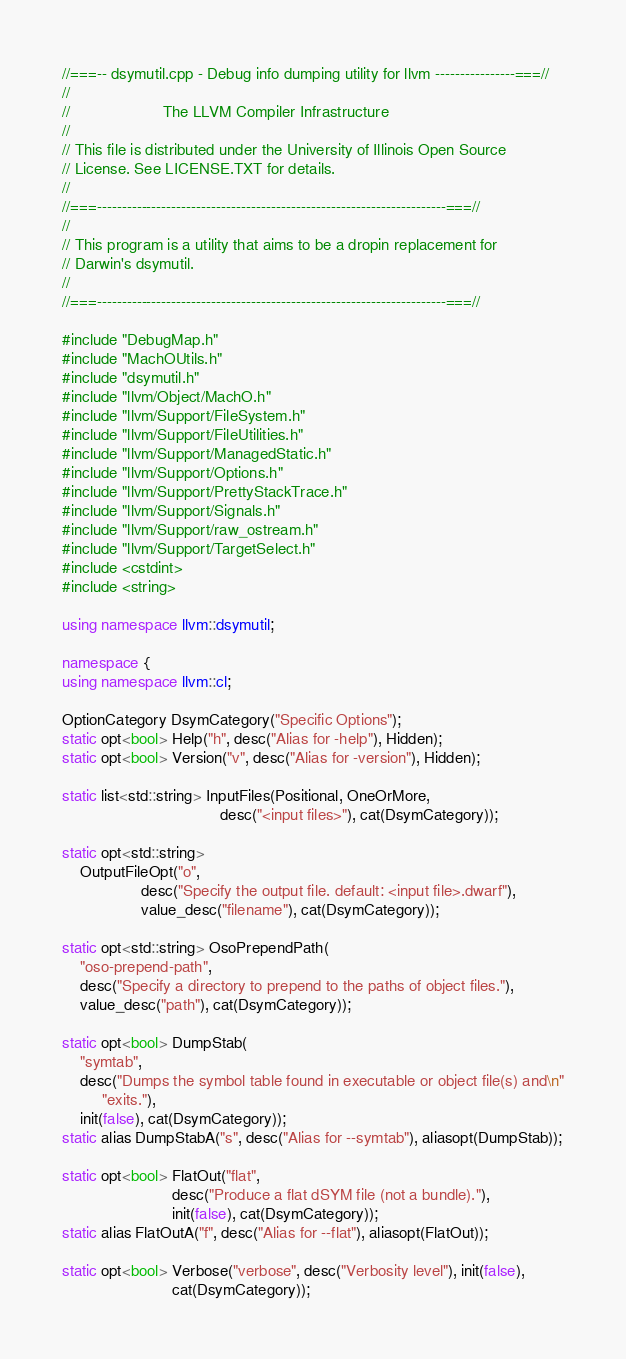<code> <loc_0><loc_0><loc_500><loc_500><_C++_>//===-- dsymutil.cpp - Debug info dumping utility for llvm ----------------===//
//
//                     The LLVM Compiler Infrastructure
//
// This file is distributed under the University of Illinois Open Source
// License. See LICENSE.TXT for details.
//
//===----------------------------------------------------------------------===//
//
// This program is a utility that aims to be a dropin replacement for
// Darwin's dsymutil.
//
//===----------------------------------------------------------------------===//

#include "DebugMap.h"
#include "MachOUtils.h"
#include "dsymutil.h"
#include "llvm/Object/MachO.h"
#include "llvm/Support/FileSystem.h"
#include "llvm/Support/FileUtilities.h"
#include "llvm/Support/ManagedStatic.h"
#include "llvm/Support/Options.h"
#include "llvm/Support/PrettyStackTrace.h"
#include "llvm/Support/Signals.h"
#include "llvm/Support/raw_ostream.h"
#include "llvm/Support/TargetSelect.h"
#include <cstdint>
#include <string>

using namespace llvm::dsymutil;

namespace {
using namespace llvm::cl;

OptionCategory DsymCategory("Specific Options");
static opt<bool> Help("h", desc("Alias for -help"), Hidden);
static opt<bool> Version("v", desc("Alias for -version"), Hidden);

static list<std::string> InputFiles(Positional, OneOrMore,
                                    desc("<input files>"), cat(DsymCategory));

static opt<std::string>
    OutputFileOpt("o",
                  desc("Specify the output file. default: <input file>.dwarf"),
                  value_desc("filename"), cat(DsymCategory));

static opt<std::string> OsoPrependPath(
    "oso-prepend-path",
    desc("Specify a directory to prepend to the paths of object files."),
    value_desc("path"), cat(DsymCategory));

static opt<bool> DumpStab(
    "symtab",
    desc("Dumps the symbol table found in executable or object file(s) and\n"
         "exits."),
    init(false), cat(DsymCategory));
static alias DumpStabA("s", desc("Alias for --symtab"), aliasopt(DumpStab));

static opt<bool> FlatOut("flat",
                         desc("Produce a flat dSYM file (not a bundle)."),
                         init(false), cat(DsymCategory));
static alias FlatOutA("f", desc("Alias for --flat"), aliasopt(FlatOut));

static opt<bool> Verbose("verbose", desc("Verbosity level"), init(false),
                         cat(DsymCategory));
</code> 